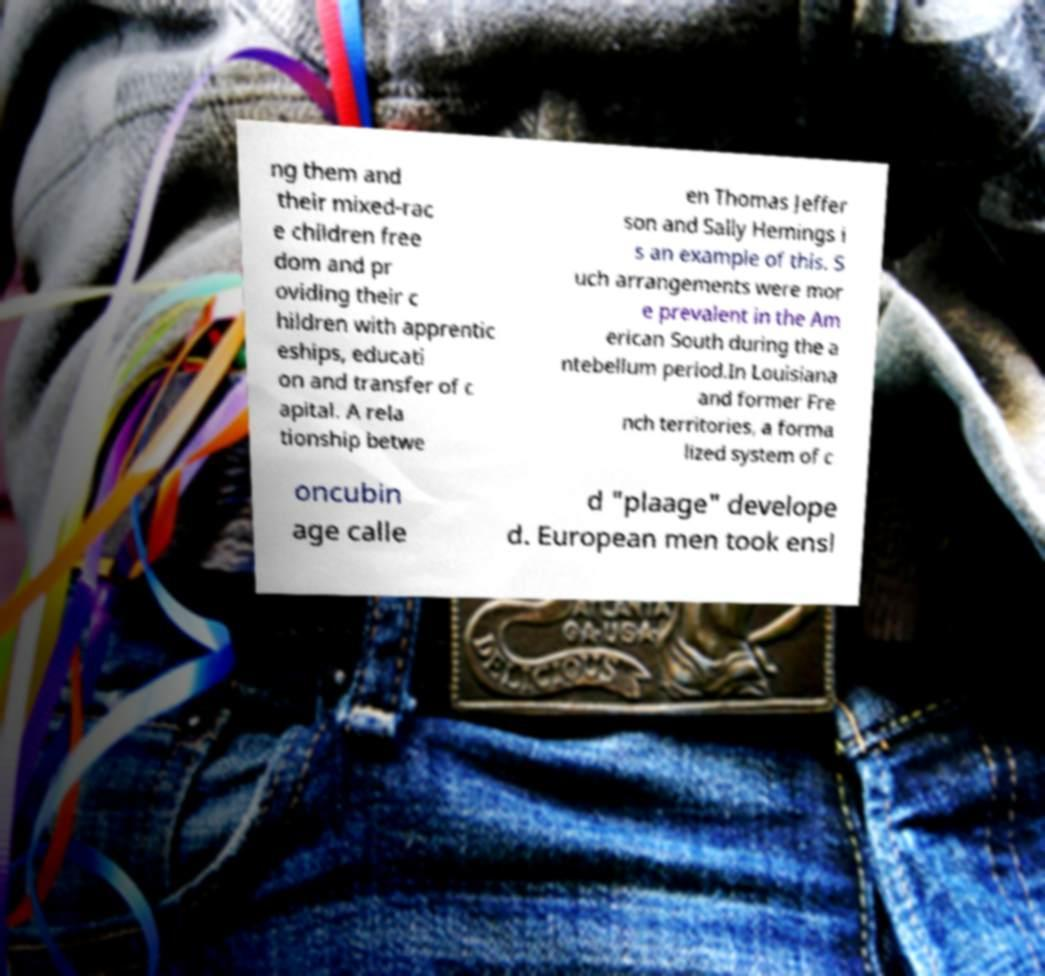Please read and relay the text visible in this image. What does it say? ng them and their mixed-rac e children free dom and pr oviding their c hildren with apprentic eships, educati on and transfer of c apital. A rela tionship betwe en Thomas Jeffer son and Sally Hemings i s an example of this. S uch arrangements were mor e prevalent in the Am erican South during the a ntebellum period.In Louisiana and former Fre nch territories, a forma lized system of c oncubin age calle d "plaage" develope d. European men took ensl 